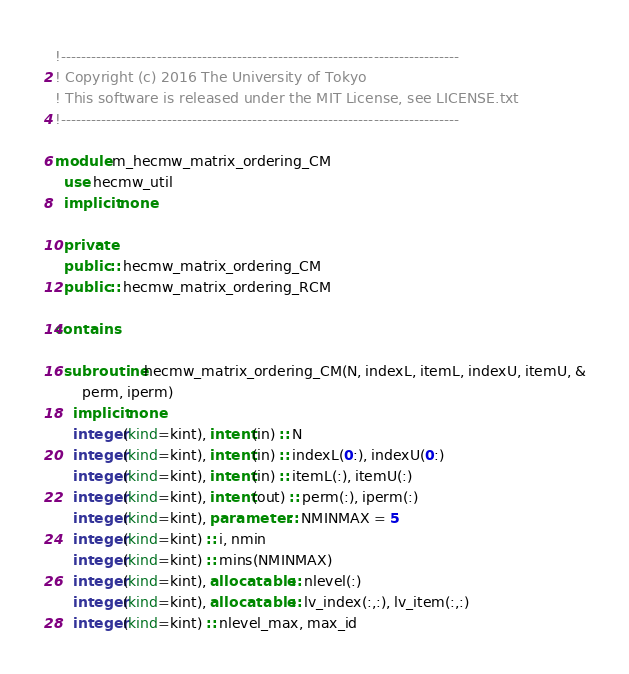<code> <loc_0><loc_0><loc_500><loc_500><_FORTRAN_>!-------------------------------------------------------------------------------
! Copyright (c) 2016 The University of Tokyo
! This software is released under the MIT License, see LICENSE.txt
!-------------------------------------------------------------------------------

module m_hecmw_matrix_ordering_CM
  use hecmw_util
  implicit none

  private
  public :: hecmw_matrix_ordering_CM
  public :: hecmw_matrix_ordering_RCM

contains

  subroutine hecmw_matrix_ordering_CM(N, indexL, itemL, indexU, itemU, &
      perm, iperm)
    implicit none
    integer(kind=kint), intent(in) :: N
    integer(kind=kint), intent(in) :: indexL(0:), indexU(0:)
    integer(kind=kint), intent(in) :: itemL(:), itemU(:)
    integer(kind=kint), intent(out) :: perm(:), iperm(:)
    integer(kind=kint), parameter :: NMINMAX = 5
    integer(kind=kint) :: i, nmin
    integer(kind=kint) :: mins(NMINMAX)
    integer(kind=kint), allocatable :: nlevel(:)
    integer(kind=kint), allocatable :: lv_index(:,:), lv_item(:,:)
    integer(kind=kint) :: nlevel_max, max_id</code> 